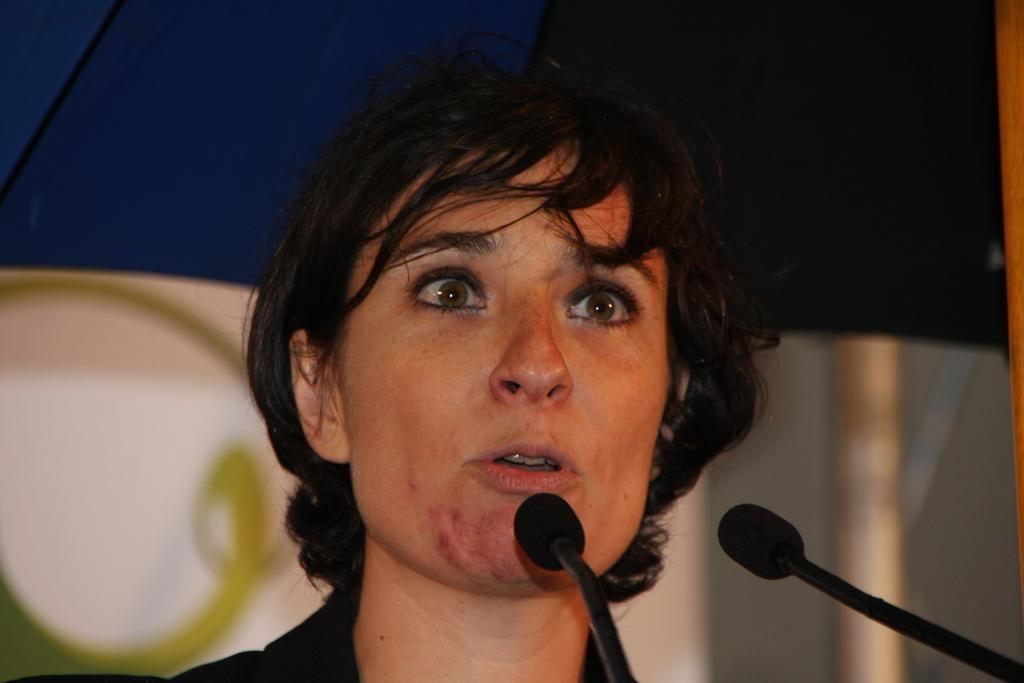Who is the main subject in the image? There is a woman in the image. What is the woman doing in the image? The woman is speaking. What objects are in front of the woman? There are microphones in front of the woman. Can you describe the background of the image? The background of the image is blurred. How many cherries are on the woman's temper in the image? There are no cherries or reference to a temper in the image. 